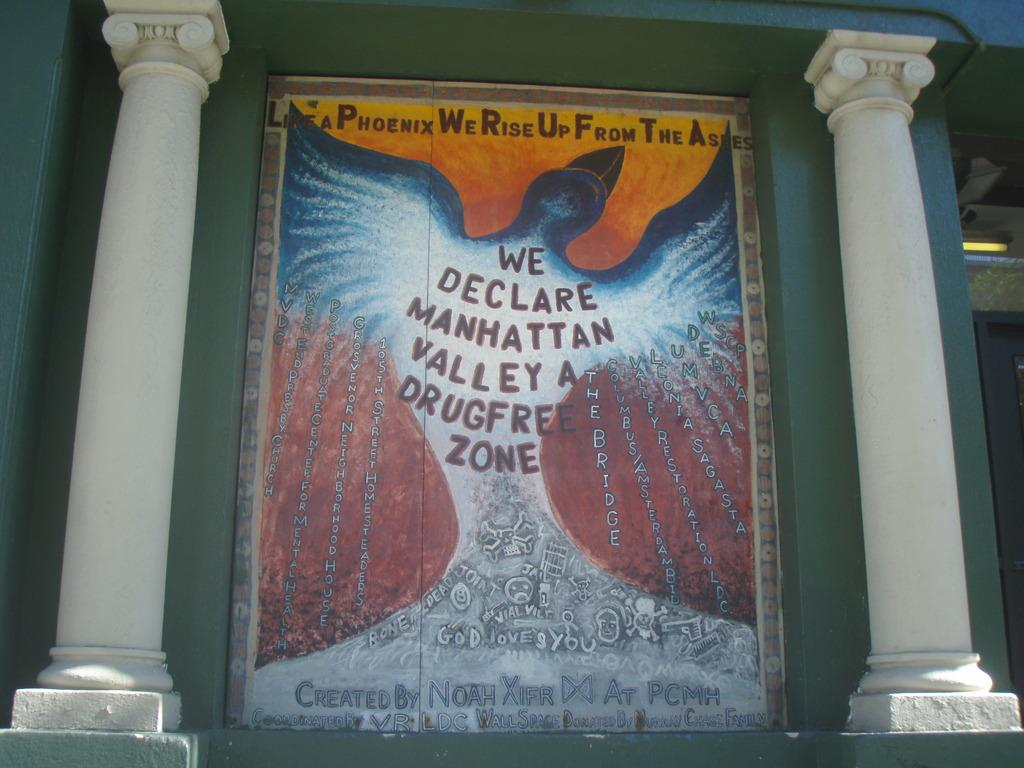Provide a one-sentence caption for the provided image. A wall mural declaring that manhattan valley is free of drugs. 